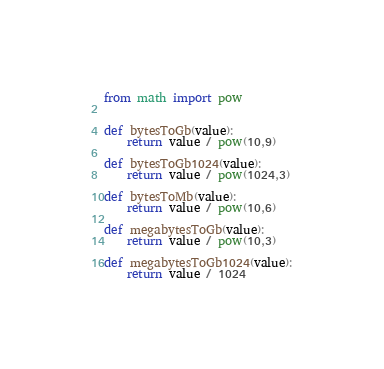Convert code to text. <code><loc_0><loc_0><loc_500><loc_500><_Python_>from math import pow


def bytesToGb(value):
    return value / pow(10,9)

def bytesToGb1024(value):
    return value / pow(1024,3)

def bytesToMb(value):
    return value / pow(10,6)

def megabytesToGb(value):
    return value / pow(10,3)

def megabytesToGb1024(value):
    return value / 1024</code> 